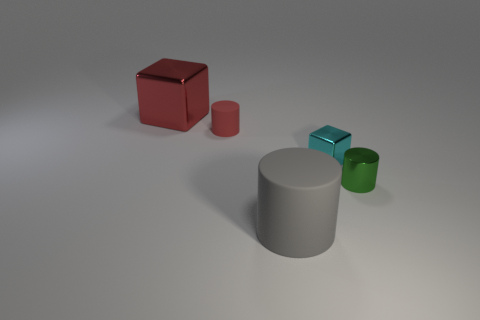Can you describe the objects and their arrangement in the image? Certainly! The image showcases five 3D-rendered objects on a plain surface under neutral lighting. There's a red cube, a large white cylinder lying horizontally, a smaller upright red cylinder, and two small cylinders, one cyan and one green. The objects are arranged with ample space between them, not following any particular pattern. Do the sizes of the objects suggest any specific relationship or pattern? The sizes of the objects don't seem to follow a specific ascending or descending order. However, the two smaller cylinders might imply a repeated element or minimal pairing, in contrast with the uniqueness of the other larger shapes. 